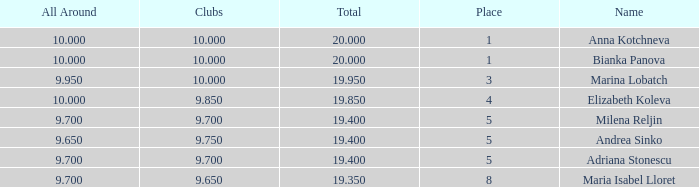What total has 10 as the clubs, with a place greater than 1? 19.95. 